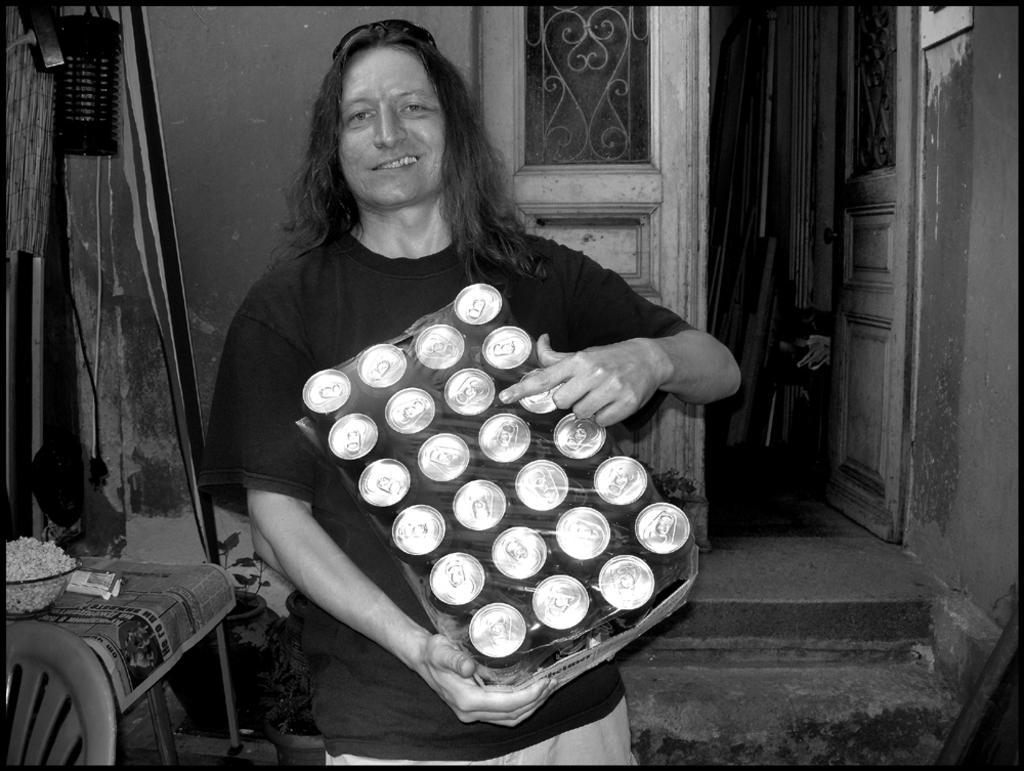How would you summarize this image in a sentence or two? This is a black and white image. In the image there is a man standing and holding the pack of tins in his hand. And there are goggles on his head. On the left side of the image there is a chair and also there is a packet and bowl with an item in it. Behind the tables there are few objects. In the background there is a wall with doors. Inside the room there are few items in it. 